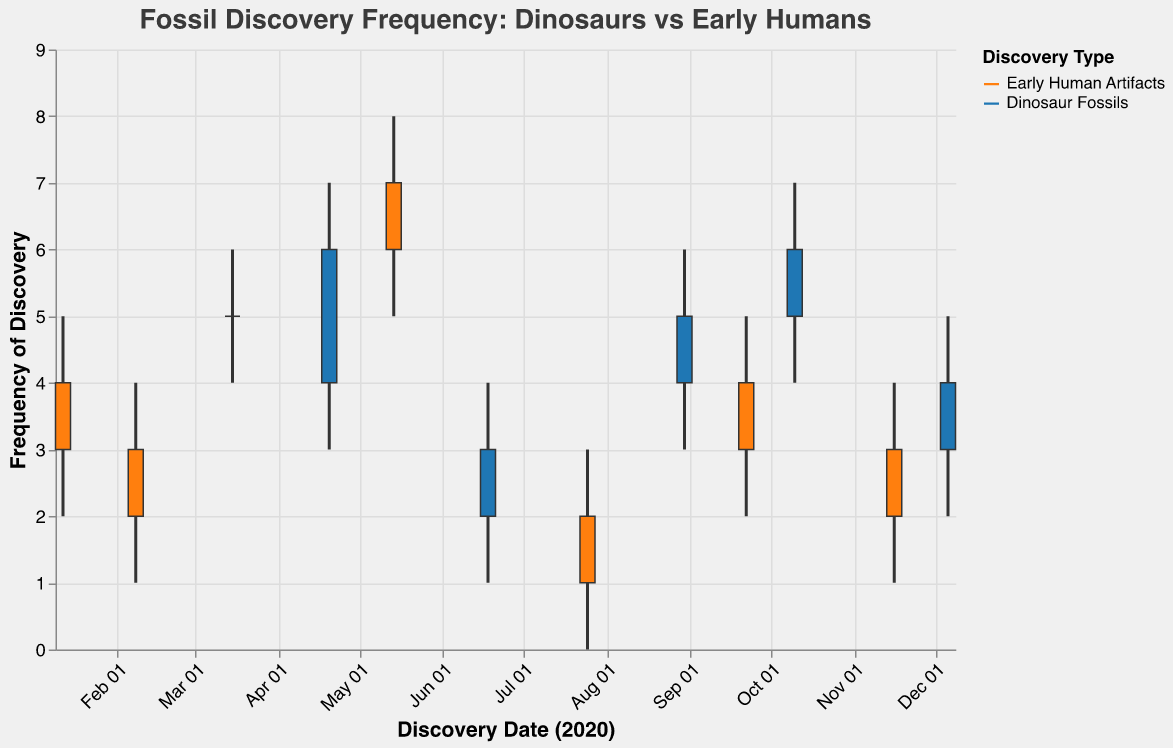What's the title of the figure? The title is located at the top of the chart and usually describes the data presented.
Answer: Fossil Discovery Frequency: Dinosaurs vs Early Humans What are the two categories represented by different colors in the plot? The legend on the right side of the chart typically identifies the categories by displaying color-coded labels.
Answer: Early Human Artifacts and Dinosaur Fossils Which discovery location has the highest recorded frequency for dinosaur fossils? By examining the vertical extent of the candlestick plots, the tallest one corresponding to dinosaur fossils represents the highest frequency.
Answer: Isle of Wight What is the frequency range of discoveries in the La Brea Tar Pits? To find the range, observe the height of the candlestick plot over La Brea Tar Pits, looking for the "High" and "Low" values.
Answer: 1 to 4 How many discoveries were recorded at Olduvai Gorge on January 12, 2020? Check the top of the candlestick for "High" and "Low" values for the specified date and location.
Answer: 2 to 5 Which type had more discoveries at Kromdraai, and by how much? Compare the "Close" values for the two categories found at Kromdraai and subtract them to find the difference.
Answer: Early Human Artifacts had 4 more discoveries than Dinosaur Fossils What is the average frequency for all discoveries made in September? Identify the values for the only location in September, sum up, and divide by the number of data points.
Answer: 3 (since the only data point is for Kebara Cave with "High" of 5 and "Low" of 2, the average is (5 + 2)/2 ) Which month showed the highest variability in fossil discoveries? Variability can be interpreted by the difference between the High and Low values. Identify the month with the widest range.
Answer: May (Kromdraai, 3 to 8) On what date was the lowest frequency of discoveries recorded, and at what location? Look for the smallest number on the y-axis looking at the "Low" value on the bar chart.
Answer: 2020-07-25, Atapuerca What is the difference between the highest and lowest "Open" values for early human artifacts? Identify the maximum and minimum "Open" values within the "Early Human Artifacts" category and subtract them.
Answer: 5 (Highest is Kromdraai at 6, lowest is Atapuerca at 1) 